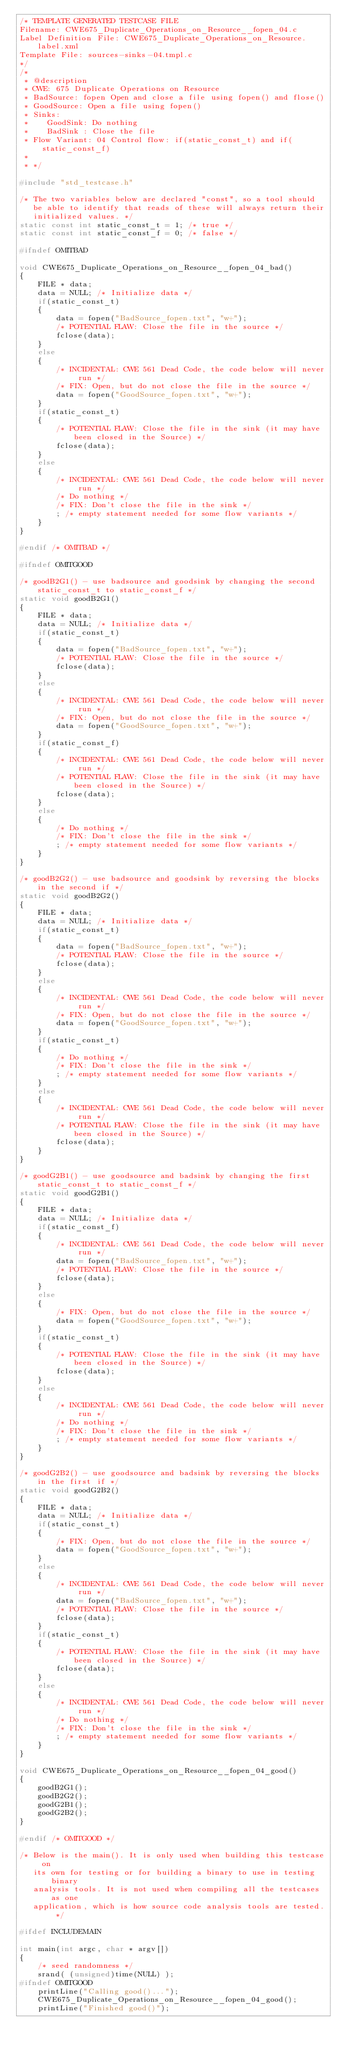<code> <loc_0><loc_0><loc_500><loc_500><_C_>/* TEMPLATE GENERATED TESTCASE FILE
Filename: CWE675_Duplicate_Operations_on_Resource__fopen_04.c
Label Definition File: CWE675_Duplicate_Operations_on_Resource.label.xml
Template File: sources-sinks-04.tmpl.c
*/
/*
 * @description
 * CWE: 675 Duplicate Operations on Resource
 * BadSource: fopen Open and close a file using fopen() and flose()
 * GoodSource: Open a file using fopen()
 * Sinks:
 *    GoodSink: Do nothing
 *    BadSink : Close the file
 * Flow Variant: 04 Control flow: if(static_const_t) and if(static_const_f)
 *
 * */

#include "std_testcase.h"

/* The two variables below are declared "const", so a tool should
   be able to identify that reads of these will always return their
   initialized values. */
static const int static_const_t = 1; /* true */
static const int static_const_f = 0; /* false */

#ifndef OMITBAD

void CWE675_Duplicate_Operations_on_Resource__fopen_04_bad()
{
    FILE * data;
    data = NULL; /* Initialize data */
    if(static_const_t)
    {
        data = fopen("BadSource_fopen.txt", "w+");
        /* POTENTIAL FLAW: Close the file in the source */
        fclose(data);
    }
    else
    {
        /* INCIDENTAL: CWE 561 Dead Code, the code below will never run */
        /* FIX: Open, but do not close the file in the source */
        data = fopen("GoodSource_fopen.txt", "w+");
    }
    if(static_const_t)
    {
        /* POTENTIAL FLAW: Close the file in the sink (it may have been closed in the Source) */
        fclose(data);
    }
    else
    {
        /* INCIDENTAL: CWE 561 Dead Code, the code below will never run */
        /* Do nothing */
        /* FIX: Don't close the file in the sink */
        ; /* empty statement needed for some flow variants */
    }
}

#endif /* OMITBAD */

#ifndef OMITGOOD

/* goodB2G1() - use badsource and goodsink by changing the second static_const_t to static_const_f */
static void goodB2G1()
{
    FILE * data;
    data = NULL; /* Initialize data */
    if(static_const_t)
    {
        data = fopen("BadSource_fopen.txt", "w+");
        /* POTENTIAL FLAW: Close the file in the source */
        fclose(data);
    }
    else
    {
        /* INCIDENTAL: CWE 561 Dead Code, the code below will never run */
        /* FIX: Open, but do not close the file in the source */
        data = fopen("GoodSource_fopen.txt", "w+");
    }
    if(static_const_f)
    {
        /* INCIDENTAL: CWE 561 Dead Code, the code below will never run */
        /* POTENTIAL FLAW: Close the file in the sink (it may have been closed in the Source) */
        fclose(data);
    }
    else
    {
        /* Do nothing */
        /* FIX: Don't close the file in the sink */
        ; /* empty statement needed for some flow variants */
    }
}

/* goodB2G2() - use badsource and goodsink by reversing the blocks in the second if */
static void goodB2G2()
{
    FILE * data;
    data = NULL; /* Initialize data */
    if(static_const_t)
    {
        data = fopen("BadSource_fopen.txt", "w+");
        /* POTENTIAL FLAW: Close the file in the source */
        fclose(data);
    }
    else
    {
        /* INCIDENTAL: CWE 561 Dead Code, the code below will never run */
        /* FIX: Open, but do not close the file in the source */
        data = fopen("GoodSource_fopen.txt", "w+");
    }
    if(static_const_t)
    {
        /* Do nothing */
        /* FIX: Don't close the file in the sink */
        ; /* empty statement needed for some flow variants */
    }
    else
    {
        /* INCIDENTAL: CWE 561 Dead Code, the code below will never run */
        /* POTENTIAL FLAW: Close the file in the sink (it may have been closed in the Source) */
        fclose(data);
    }
}

/* goodG2B1() - use goodsource and badsink by changing the first static_const_t to static_const_f */
static void goodG2B1()
{
    FILE * data;
    data = NULL; /* Initialize data */
    if(static_const_f)
    {
        /* INCIDENTAL: CWE 561 Dead Code, the code below will never run */
        data = fopen("BadSource_fopen.txt", "w+");
        /* POTENTIAL FLAW: Close the file in the source */
        fclose(data);
    }
    else
    {
        /* FIX: Open, but do not close the file in the source */
        data = fopen("GoodSource_fopen.txt", "w+");
    }
    if(static_const_t)
    {
        /* POTENTIAL FLAW: Close the file in the sink (it may have been closed in the Source) */
        fclose(data);
    }
    else
    {
        /* INCIDENTAL: CWE 561 Dead Code, the code below will never run */
        /* Do nothing */
        /* FIX: Don't close the file in the sink */
        ; /* empty statement needed for some flow variants */
    }
}

/* goodG2B2() - use goodsource and badsink by reversing the blocks in the first if */
static void goodG2B2()
{
    FILE * data;
    data = NULL; /* Initialize data */
    if(static_const_t)
    {
        /* FIX: Open, but do not close the file in the source */
        data = fopen("GoodSource_fopen.txt", "w+");
    }
    else
    {
        /* INCIDENTAL: CWE 561 Dead Code, the code below will never run */
        data = fopen("BadSource_fopen.txt", "w+");
        /* POTENTIAL FLAW: Close the file in the source */
        fclose(data);
    }
    if(static_const_t)
    {
        /* POTENTIAL FLAW: Close the file in the sink (it may have been closed in the Source) */
        fclose(data);
    }
    else
    {
        /* INCIDENTAL: CWE 561 Dead Code, the code below will never run */
        /* Do nothing */
        /* FIX: Don't close the file in the sink */
        ; /* empty statement needed for some flow variants */
    }
}

void CWE675_Duplicate_Operations_on_Resource__fopen_04_good()
{
    goodB2G1();
    goodB2G2();
    goodG2B1();
    goodG2B2();
}

#endif /* OMITGOOD */

/* Below is the main(). It is only used when building this testcase on
   its own for testing or for building a binary to use in testing binary
   analysis tools. It is not used when compiling all the testcases as one
   application, which is how source code analysis tools are tested. */

#ifdef INCLUDEMAIN

int main(int argc, char * argv[])
{
    /* seed randomness */
    srand( (unsigned)time(NULL) );
#ifndef OMITGOOD
    printLine("Calling good()...");
    CWE675_Duplicate_Operations_on_Resource__fopen_04_good();
    printLine("Finished good()");</code> 